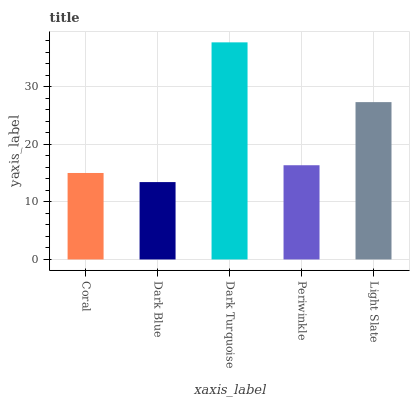Is Dark Blue the minimum?
Answer yes or no. Yes. Is Dark Turquoise the maximum?
Answer yes or no. Yes. Is Dark Turquoise the minimum?
Answer yes or no. No. Is Dark Blue the maximum?
Answer yes or no. No. Is Dark Turquoise greater than Dark Blue?
Answer yes or no. Yes. Is Dark Blue less than Dark Turquoise?
Answer yes or no. Yes. Is Dark Blue greater than Dark Turquoise?
Answer yes or no. No. Is Dark Turquoise less than Dark Blue?
Answer yes or no. No. Is Periwinkle the high median?
Answer yes or no. Yes. Is Periwinkle the low median?
Answer yes or no. Yes. Is Dark Turquoise the high median?
Answer yes or no. No. Is Light Slate the low median?
Answer yes or no. No. 